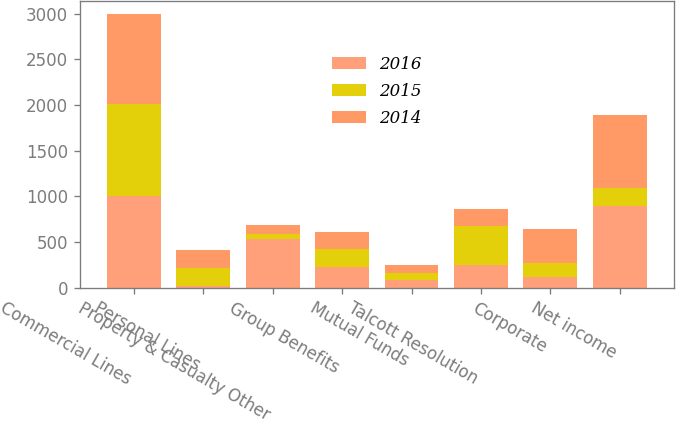Convert chart to OTSL. <chart><loc_0><loc_0><loc_500><loc_500><stacked_bar_chart><ecel><fcel>Commercial Lines<fcel>Personal Lines<fcel>Property & Casualty Other<fcel>Group Benefits<fcel>Mutual Funds<fcel>Talcott Resolution<fcel>Corporate<fcel>Net income<nl><fcel>2016<fcel>1007<fcel>22<fcel>529<fcel>230<fcel>78<fcel>244<fcel>112<fcel>896<nl><fcel>2015<fcel>1003<fcel>187<fcel>53<fcel>187<fcel>86<fcel>430<fcel>158<fcel>191<nl><fcel>2014<fcel>983<fcel>207<fcel>108<fcel>191<fcel>87<fcel>187<fcel>375<fcel>798<nl></chart> 